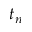Convert formula to latex. <formula><loc_0><loc_0><loc_500><loc_500>t _ { n }</formula> 